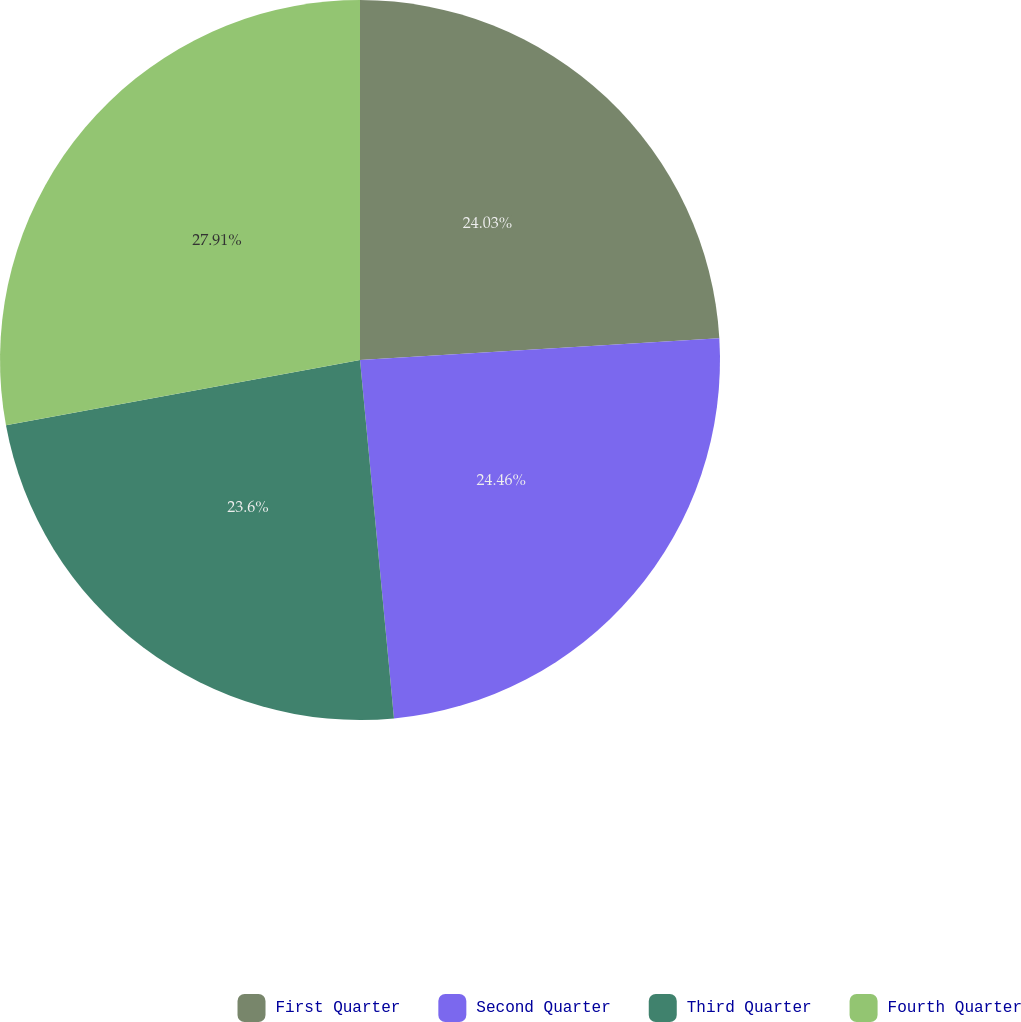Convert chart to OTSL. <chart><loc_0><loc_0><loc_500><loc_500><pie_chart><fcel>First Quarter<fcel>Second Quarter<fcel>Third Quarter<fcel>Fourth Quarter<nl><fcel>24.03%<fcel>24.46%<fcel>23.6%<fcel>27.9%<nl></chart> 